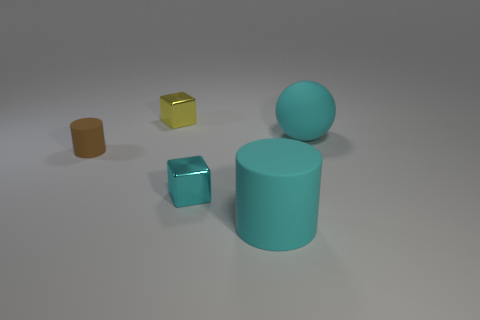Add 4 metallic blocks. How many objects exist? 9 Subtract all balls. How many objects are left? 4 Subtract all large gray blocks. Subtract all tiny yellow metal things. How many objects are left? 4 Add 5 metal things. How many metal things are left? 7 Add 2 small yellow metal blocks. How many small yellow metal blocks exist? 3 Subtract 0 brown blocks. How many objects are left? 5 Subtract all gray balls. Subtract all blue cubes. How many balls are left? 1 Subtract all red balls. How many yellow blocks are left? 1 